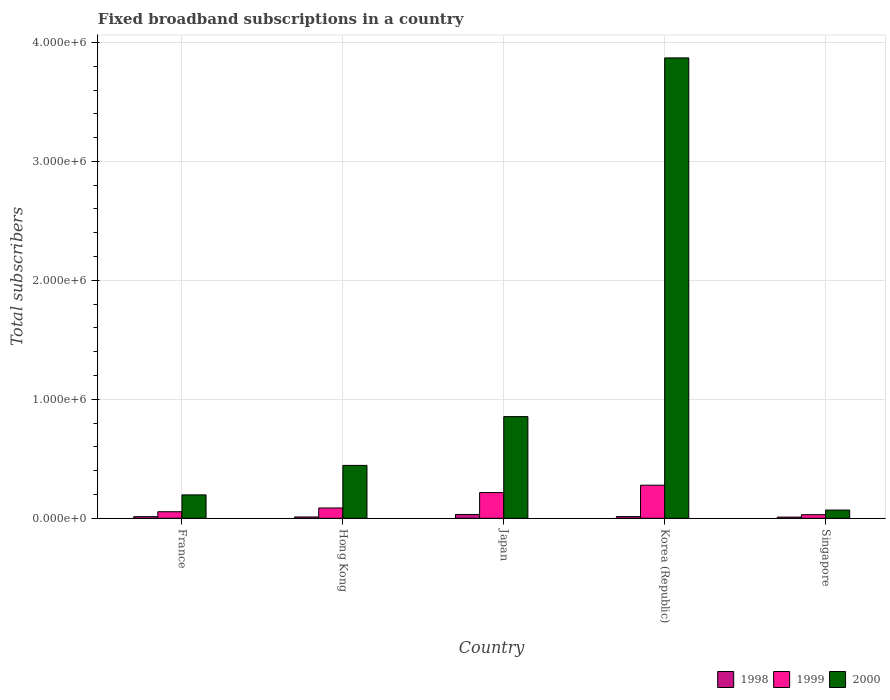How many different coloured bars are there?
Your answer should be very brief. 3. Are the number of bars on each tick of the X-axis equal?
Keep it short and to the point. Yes. How many bars are there on the 3rd tick from the left?
Provide a short and direct response. 3. How many bars are there on the 4th tick from the right?
Ensure brevity in your answer.  3. What is the label of the 5th group of bars from the left?
Keep it short and to the point. Singapore. What is the number of broadband subscriptions in 1998 in Singapore?
Ensure brevity in your answer.  10000. Across all countries, what is the maximum number of broadband subscriptions in 1999?
Your answer should be compact. 2.78e+05. Across all countries, what is the minimum number of broadband subscriptions in 1999?
Your answer should be compact. 3.00e+04. In which country was the number of broadband subscriptions in 2000 maximum?
Give a very brief answer. Korea (Republic). In which country was the number of broadband subscriptions in 1999 minimum?
Make the answer very short. Singapore. What is the total number of broadband subscriptions in 1998 in the graph?
Make the answer very short. 8.05e+04. What is the difference between the number of broadband subscriptions in 2000 in France and that in Japan?
Your response must be concise. -6.58e+05. What is the difference between the number of broadband subscriptions in 2000 in France and the number of broadband subscriptions in 1999 in Korea (Republic)?
Offer a very short reply. -8.14e+04. What is the average number of broadband subscriptions in 1999 per country?
Your answer should be compact. 1.33e+05. What is the difference between the number of broadband subscriptions of/in 2000 and number of broadband subscriptions of/in 1998 in Korea (Republic)?
Provide a succinct answer. 3.86e+06. In how many countries, is the number of broadband subscriptions in 1999 greater than 2400000?
Provide a succinct answer. 0. What is the ratio of the number of broadband subscriptions in 1998 in France to that in Japan?
Your answer should be compact. 0.42. What is the difference between the highest and the second highest number of broadband subscriptions in 1998?
Give a very brief answer. 1.85e+04. What is the difference between the highest and the lowest number of broadband subscriptions in 1999?
Provide a succinct answer. 2.48e+05. Is the sum of the number of broadband subscriptions in 1998 in France and Singapore greater than the maximum number of broadband subscriptions in 2000 across all countries?
Ensure brevity in your answer.  No. What does the 1st bar from the left in France represents?
Your response must be concise. 1998. What does the 1st bar from the right in Korea (Republic) represents?
Give a very brief answer. 2000. How many bars are there?
Provide a succinct answer. 15. How many countries are there in the graph?
Provide a short and direct response. 5. What is the difference between two consecutive major ticks on the Y-axis?
Offer a terse response. 1.00e+06. Does the graph contain grids?
Provide a short and direct response. Yes. How are the legend labels stacked?
Your response must be concise. Horizontal. What is the title of the graph?
Your response must be concise. Fixed broadband subscriptions in a country. Does "1989" appear as one of the legend labels in the graph?
Offer a very short reply. No. What is the label or title of the Y-axis?
Your answer should be very brief. Total subscribers. What is the Total subscribers of 1998 in France?
Your answer should be very brief. 1.35e+04. What is the Total subscribers in 1999 in France?
Your answer should be very brief. 5.50e+04. What is the Total subscribers in 2000 in France?
Make the answer very short. 1.97e+05. What is the Total subscribers of 1998 in Hong Kong?
Keep it short and to the point. 1.10e+04. What is the Total subscribers of 1999 in Hong Kong?
Your response must be concise. 8.65e+04. What is the Total subscribers of 2000 in Hong Kong?
Provide a succinct answer. 4.44e+05. What is the Total subscribers of 1998 in Japan?
Your answer should be compact. 3.20e+04. What is the Total subscribers of 1999 in Japan?
Offer a terse response. 2.16e+05. What is the Total subscribers of 2000 in Japan?
Make the answer very short. 8.55e+05. What is the Total subscribers in 1998 in Korea (Republic)?
Your answer should be compact. 1.40e+04. What is the Total subscribers of 1999 in Korea (Republic)?
Ensure brevity in your answer.  2.78e+05. What is the Total subscribers in 2000 in Korea (Republic)?
Your response must be concise. 3.87e+06. What is the Total subscribers in 2000 in Singapore?
Provide a succinct answer. 6.90e+04. Across all countries, what is the maximum Total subscribers of 1998?
Your response must be concise. 3.20e+04. Across all countries, what is the maximum Total subscribers of 1999?
Your response must be concise. 2.78e+05. Across all countries, what is the maximum Total subscribers in 2000?
Your response must be concise. 3.87e+06. Across all countries, what is the minimum Total subscribers of 1998?
Your answer should be compact. 10000. Across all countries, what is the minimum Total subscribers of 2000?
Your response must be concise. 6.90e+04. What is the total Total subscribers of 1998 in the graph?
Offer a terse response. 8.05e+04. What is the total Total subscribers of 1999 in the graph?
Your answer should be compact. 6.65e+05. What is the total Total subscribers in 2000 in the graph?
Give a very brief answer. 5.43e+06. What is the difference between the Total subscribers of 1998 in France and that in Hong Kong?
Offer a terse response. 2464. What is the difference between the Total subscribers in 1999 in France and that in Hong Kong?
Your response must be concise. -3.15e+04. What is the difference between the Total subscribers in 2000 in France and that in Hong Kong?
Give a very brief answer. -2.48e+05. What is the difference between the Total subscribers of 1998 in France and that in Japan?
Provide a succinct answer. -1.85e+04. What is the difference between the Total subscribers in 1999 in France and that in Japan?
Your answer should be very brief. -1.61e+05. What is the difference between the Total subscribers of 2000 in France and that in Japan?
Ensure brevity in your answer.  -6.58e+05. What is the difference between the Total subscribers in 1998 in France and that in Korea (Republic)?
Provide a short and direct response. -536. What is the difference between the Total subscribers of 1999 in France and that in Korea (Republic)?
Offer a terse response. -2.23e+05. What is the difference between the Total subscribers in 2000 in France and that in Korea (Republic)?
Your response must be concise. -3.67e+06. What is the difference between the Total subscribers of 1998 in France and that in Singapore?
Provide a short and direct response. 3464. What is the difference between the Total subscribers in 1999 in France and that in Singapore?
Provide a short and direct response. 2.50e+04. What is the difference between the Total subscribers of 2000 in France and that in Singapore?
Offer a very short reply. 1.28e+05. What is the difference between the Total subscribers in 1998 in Hong Kong and that in Japan?
Make the answer very short. -2.10e+04. What is the difference between the Total subscribers in 1999 in Hong Kong and that in Japan?
Offer a very short reply. -1.30e+05. What is the difference between the Total subscribers of 2000 in Hong Kong and that in Japan?
Give a very brief answer. -4.10e+05. What is the difference between the Total subscribers in 1998 in Hong Kong and that in Korea (Republic)?
Provide a succinct answer. -3000. What is the difference between the Total subscribers in 1999 in Hong Kong and that in Korea (Republic)?
Your response must be concise. -1.92e+05. What is the difference between the Total subscribers in 2000 in Hong Kong and that in Korea (Republic)?
Your response must be concise. -3.43e+06. What is the difference between the Total subscribers in 1998 in Hong Kong and that in Singapore?
Give a very brief answer. 1000. What is the difference between the Total subscribers of 1999 in Hong Kong and that in Singapore?
Your answer should be very brief. 5.65e+04. What is the difference between the Total subscribers of 2000 in Hong Kong and that in Singapore?
Provide a short and direct response. 3.75e+05. What is the difference between the Total subscribers in 1998 in Japan and that in Korea (Republic)?
Your response must be concise. 1.80e+04. What is the difference between the Total subscribers in 1999 in Japan and that in Korea (Republic)?
Your response must be concise. -6.20e+04. What is the difference between the Total subscribers of 2000 in Japan and that in Korea (Republic)?
Keep it short and to the point. -3.02e+06. What is the difference between the Total subscribers in 1998 in Japan and that in Singapore?
Give a very brief answer. 2.20e+04. What is the difference between the Total subscribers in 1999 in Japan and that in Singapore?
Offer a terse response. 1.86e+05. What is the difference between the Total subscribers of 2000 in Japan and that in Singapore?
Give a very brief answer. 7.86e+05. What is the difference between the Total subscribers of 1998 in Korea (Republic) and that in Singapore?
Your response must be concise. 4000. What is the difference between the Total subscribers in 1999 in Korea (Republic) and that in Singapore?
Give a very brief answer. 2.48e+05. What is the difference between the Total subscribers in 2000 in Korea (Republic) and that in Singapore?
Offer a very short reply. 3.80e+06. What is the difference between the Total subscribers of 1998 in France and the Total subscribers of 1999 in Hong Kong?
Provide a succinct answer. -7.30e+04. What is the difference between the Total subscribers of 1998 in France and the Total subscribers of 2000 in Hong Kong?
Your answer should be compact. -4.31e+05. What is the difference between the Total subscribers in 1999 in France and the Total subscribers in 2000 in Hong Kong?
Your response must be concise. -3.89e+05. What is the difference between the Total subscribers in 1998 in France and the Total subscribers in 1999 in Japan?
Your answer should be compact. -2.03e+05. What is the difference between the Total subscribers of 1998 in France and the Total subscribers of 2000 in Japan?
Give a very brief answer. -8.41e+05. What is the difference between the Total subscribers of 1999 in France and the Total subscribers of 2000 in Japan?
Provide a short and direct response. -8.00e+05. What is the difference between the Total subscribers in 1998 in France and the Total subscribers in 1999 in Korea (Republic)?
Provide a succinct answer. -2.65e+05. What is the difference between the Total subscribers in 1998 in France and the Total subscribers in 2000 in Korea (Republic)?
Offer a terse response. -3.86e+06. What is the difference between the Total subscribers in 1999 in France and the Total subscribers in 2000 in Korea (Republic)?
Ensure brevity in your answer.  -3.82e+06. What is the difference between the Total subscribers of 1998 in France and the Total subscribers of 1999 in Singapore?
Make the answer very short. -1.65e+04. What is the difference between the Total subscribers in 1998 in France and the Total subscribers in 2000 in Singapore?
Give a very brief answer. -5.55e+04. What is the difference between the Total subscribers of 1999 in France and the Total subscribers of 2000 in Singapore?
Provide a short and direct response. -1.40e+04. What is the difference between the Total subscribers in 1998 in Hong Kong and the Total subscribers in 1999 in Japan?
Offer a terse response. -2.05e+05. What is the difference between the Total subscribers of 1998 in Hong Kong and the Total subscribers of 2000 in Japan?
Make the answer very short. -8.44e+05. What is the difference between the Total subscribers in 1999 in Hong Kong and the Total subscribers in 2000 in Japan?
Offer a very short reply. -7.68e+05. What is the difference between the Total subscribers of 1998 in Hong Kong and the Total subscribers of 1999 in Korea (Republic)?
Offer a terse response. -2.67e+05. What is the difference between the Total subscribers in 1998 in Hong Kong and the Total subscribers in 2000 in Korea (Republic)?
Provide a short and direct response. -3.86e+06. What is the difference between the Total subscribers in 1999 in Hong Kong and the Total subscribers in 2000 in Korea (Republic)?
Your answer should be very brief. -3.78e+06. What is the difference between the Total subscribers of 1998 in Hong Kong and the Total subscribers of 1999 in Singapore?
Offer a terse response. -1.90e+04. What is the difference between the Total subscribers of 1998 in Hong Kong and the Total subscribers of 2000 in Singapore?
Provide a succinct answer. -5.80e+04. What is the difference between the Total subscribers in 1999 in Hong Kong and the Total subscribers in 2000 in Singapore?
Ensure brevity in your answer.  1.75e+04. What is the difference between the Total subscribers in 1998 in Japan and the Total subscribers in 1999 in Korea (Republic)?
Provide a short and direct response. -2.46e+05. What is the difference between the Total subscribers of 1998 in Japan and the Total subscribers of 2000 in Korea (Republic)?
Provide a succinct answer. -3.84e+06. What is the difference between the Total subscribers of 1999 in Japan and the Total subscribers of 2000 in Korea (Republic)?
Your answer should be very brief. -3.65e+06. What is the difference between the Total subscribers of 1998 in Japan and the Total subscribers of 1999 in Singapore?
Ensure brevity in your answer.  2000. What is the difference between the Total subscribers in 1998 in Japan and the Total subscribers in 2000 in Singapore?
Offer a terse response. -3.70e+04. What is the difference between the Total subscribers in 1999 in Japan and the Total subscribers in 2000 in Singapore?
Provide a short and direct response. 1.47e+05. What is the difference between the Total subscribers in 1998 in Korea (Republic) and the Total subscribers in 1999 in Singapore?
Provide a short and direct response. -1.60e+04. What is the difference between the Total subscribers in 1998 in Korea (Republic) and the Total subscribers in 2000 in Singapore?
Offer a very short reply. -5.50e+04. What is the difference between the Total subscribers in 1999 in Korea (Republic) and the Total subscribers in 2000 in Singapore?
Keep it short and to the point. 2.09e+05. What is the average Total subscribers of 1998 per country?
Ensure brevity in your answer.  1.61e+04. What is the average Total subscribers of 1999 per country?
Give a very brief answer. 1.33e+05. What is the average Total subscribers in 2000 per country?
Provide a succinct answer. 1.09e+06. What is the difference between the Total subscribers in 1998 and Total subscribers in 1999 in France?
Keep it short and to the point. -4.15e+04. What is the difference between the Total subscribers in 1998 and Total subscribers in 2000 in France?
Keep it short and to the point. -1.83e+05. What is the difference between the Total subscribers in 1999 and Total subscribers in 2000 in France?
Make the answer very short. -1.42e+05. What is the difference between the Total subscribers in 1998 and Total subscribers in 1999 in Hong Kong?
Your answer should be very brief. -7.55e+04. What is the difference between the Total subscribers in 1998 and Total subscribers in 2000 in Hong Kong?
Provide a short and direct response. -4.33e+05. What is the difference between the Total subscribers in 1999 and Total subscribers in 2000 in Hong Kong?
Give a very brief answer. -3.58e+05. What is the difference between the Total subscribers in 1998 and Total subscribers in 1999 in Japan?
Give a very brief answer. -1.84e+05. What is the difference between the Total subscribers in 1998 and Total subscribers in 2000 in Japan?
Your response must be concise. -8.23e+05. What is the difference between the Total subscribers of 1999 and Total subscribers of 2000 in Japan?
Offer a terse response. -6.39e+05. What is the difference between the Total subscribers in 1998 and Total subscribers in 1999 in Korea (Republic)?
Your answer should be compact. -2.64e+05. What is the difference between the Total subscribers of 1998 and Total subscribers of 2000 in Korea (Republic)?
Your response must be concise. -3.86e+06. What is the difference between the Total subscribers in 1999 and Total subscribers in 2000 in Korea (Republic)?
Your answer should be very brief. -3.59e+06. What is the difference between the Total subscribers of 1998 and Total subscribers of 1999 in Singapore?
Give a very brief answer. -2.00e+04. What is the difference between the Total subscribers in 1998 and Total subscribers in 2000 in Singapore?
Give a very brief answer. -5.90e+04. What is the difference between the Total subscribers of 1999 and Total subscribers of 2000 in Singapore?
Offer a terse response. -3.90e+04. What is the ratio of the Total subscribers in 1998 in France to that in Hong Kong?
Your response must be concise. 1.22. What is the ratio of the Total subscribers of 1999 in France to that in Hong Kong?
Keep it short and to the point. 0.64. What is the ratio of the Total subscribers in 2000 in France to that in Hong Kong?
Your answer should be compact. 0.44. What is the ratio of the Total subscribers of 1998 in France to that in Japan?
Provide a short and direct response. 0.42. What is the ratio of the Total subscribers in 1999 in France to that in Japan?
Keep it short and to the point. 0.25. What is the ratio of the Total subscribers of 2000 in France to that in Japan?
Your answer should be very brief. 0.23. What is the ratio of the Total subscribers in 1998 in France to that in Korea (Republic)?
Offer a very short reply. 0.96. What is the ratio of the Total subscribers of 1999 in France to that in Korea (Republic)?
Make the answer very short. 0.2. What is the ratio of the Total subscribers in 2000 in France to that in Korea (Republic)?
Give a very brief answer. 0.05. What is the ratio of the Total subscribers in 1998 in France to that in Singapore?
Give a very brief answer. 1.35. What is the ratio of the Total subscribers of 1999 in France to that in Singapore?
Your answer should be compact. 1.83. What is the ratio of the Total subscribers of 2000 in France to that in Singapore?
Offer a terse response. 2.85. What is the ratio of the Total subscribers of 1998 in Hong Kong to that in Japan?
Ensure brevity in your answer.  0.34. What is the ratio of the Total subscribers in 1999 in Hong Kong to that in Japan?
Provide a short and direct response. 0.4. What is the ratio of the Total subscribers of 2000 in Hong Kong to that in Japan?
Offer a very short reply. 0.52. What is the ratio of the Total subscribers of 1998 in Hong Kong to that in Korea (Republic)?
Your response must be concise. 0.79. What is the ratio of the Total subscribers of 1999 in Hong Kong to that in Korea (Republic)?
Ensure brevity in your answer.  0.31. What is the ratio of the Total subscribers in 2000 in Hong Kong to that in Korea (Republic)?
Keep it short and to the point. 0.11. What is the ratio of the Total subscribers in 1999 in Hong Kong to that in Singapore?
Give a very brief answer. 2.88. What is the ratio of the Total subscribers of 2000 in Hong Kong to that in Singapore?
Give a very brief answer. 6.44. What is the ratio of the Total subscribers of 1998 in Japan to that in Korea (Republic)?
Offer a very short reply. 2.29. What is the ratio of the Total subscribers in 1999 in Japan to that in Korea (Republic)?
Ensure brevity in your answer.  0.78. What is the ratio of the Total subscribers in 2000 in Japan to that in Korea (Republic)?
Your response must be concise. 0.22. What is the ratio of the Total subscribers in 2000 in Japan to that in Singapore?
Provide a short and direct response. 12.39. What is the ratio of the Total subscribers of 1999 in Korea (Republic) to that in Singapore?
Your answer should be very brief. 9.27. What is the ratio of the Total subscribers in 2000 in Korea (Republic) to that in Singapore?
Keep it short and to the point. 56.09. What is the difference between the highest and the second highest Total subscribers in 1998?
Make the answer very short. 1.80e+04. What is the difference between the highest and the second highest Total subscribers in 1999?
Ensure brevity in your answer.  6.20e+04. What is the difference between the highest and the second highest Total subscribers of 2000?
Provide a short and direct response. 3.02e+06. What is the difference between the highest and the lowest Total subscribers of 1998?
Make the answer very short. 2.20e+04. What is the difference between the highest and the lowest Total subscribers of 1999?
Provide a short and direct response. 2.48e+05. What is the difference between the highest and the lowest Total subscribers in 2000?
Provide a short and direct response. 3.80e+06. 